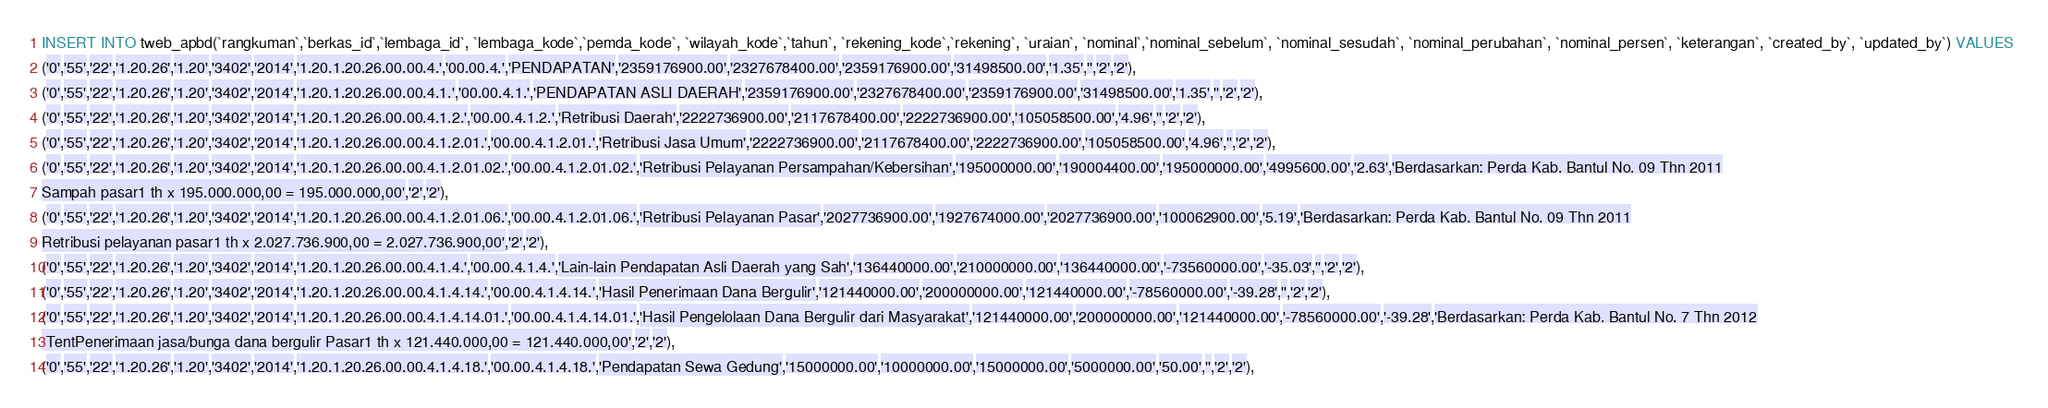<code> <loc_0><loc_0><loc_500><loc_500><_SQL_>INSERT INTO tweb_apbd(`rangkuman`,`berkas_id`,`lembaga_id`, `lembaga_kode`,`pemda_kode`, `wilayah_kode`,`tahun`, `rekening_kode`,`rekening`, `uraian`, `nominal`,`nominal_sebelum`, `nominal_sesudah`, `nominal_perubahan`, `nominal_persen`, `keterangan`, `created_by`, `updated_by`) VALUES 
('0','55','22','1.20.26','1.20','3402','2014','1.20.1.20.26.00.00.4.','00.00.4.','PENDAPATAN','2359176900.00','2327678400.00','2359176900.00','31498500.00','1.35','','2','2'),
('0','55','22','1.20.26','1.20','3402','2014','1.20.1.20.26.00.00.4.1.','00.00.4.1.','PENDAPATAN ASLI DAERAH','2359176900.00','2327678400.00','2359176900.00','31498500.00','1.35','','2','2'),
('0','55','22','1.20.26','1.20','3402','2014','1.20.1.20.26.00.00.4.1.2.','00.00.4.1.2.','Retribusi Daerah','2222736900.00','2117678400.00','2222736900.00','105058500.00','4.96','','2','2'),
('0','55','22','1.20.26','1.20','3402','2014','1.20.1.20.26.00.00.4.1.2.01.','00.00.4.1.2.01.','Retribusi Jasa Umum','2222736900.00','2117678400.00','2222736900.00','105058500.00','4.96','','2','2'),
('0','55','22','1.20.26','1.20','3402','2014','1.20.1.20.26.00.00.4.1.2.01.02.','00.00.4.1.2.01.02.','Retribusi Pelayanan Persampahan/Kebersihan','195000000.00','190004400.00','195000000.00','4995600.00','2.63','Berdasarkan: Perda Kab. Bantul No. 09 Thn 2011
Sampah pasar1 th x 195.000.000,00 = 195.000.000,00','2','2'),
('0','55','22','1.20.26','1.20','3402','2014','1.20.1.20.26.00.00.4.1.2.01.06.','00.00.4.1.2.01.06.','Retribusi Pelayanan Pasar','2027736900.00','1927674000.00','2027736900.00','100062900.00','5.19','Berdasarkan: Perda Kab. Bantul No. 09 Thn 2011
Retribusi pelayanan pasar1 th x 2.027.736.900,00 = 2.027.736.900,00','2','2'),
('0','55','22','1.20.26','1.20','3402','2014','1.20.1.20.26.00.00.4.1.4.','00.00.4.1.4.','Lain-lain Pendapatan Asli Daerah yang Sah','136440000.00','210000000.00','136440000.00','-73560000.00','-35.03','','2','2'),
('0','55','22','1.20.26','1.20','3402','2014','1.20.1.20.26.00.00.4.1.4.14.','00.00.4.1.4.14.','Hasil Penerimaan Dana Bergulir','121440000.00','200000000.00','121440000.00','-78560000.00','-39.28','','2','2'),
('0','55','22','1.20.26','1.20','3402','2014','1.20.1.20.26.00.00.4.1.4.14.01.','00.00.4.1.4.14.01.','Hasil Pengelolaan Dana Bergulir dari Masyarakat','121440000.00','200000000.00','121440000.00','-78560000.00','-39.28','Berdasarkan: Perda Kab. Bantul No. 7 Thn 2012
 TentPenerimaan jasa/bunga dana bergulir Pasar1 th x 121.440.000,00 = 121.440.000,00','2','2'),
('0','55','22','1.20.26','1.20','3402','2014','1.20.1.20.26.00.00.4.1.4.18.','00.00.4.1.4.18.','Pendapatan Sewa Gedung','15000000.00','10000000.00','15000000.00','5000000.00','50.00','','2','2'),</code> 